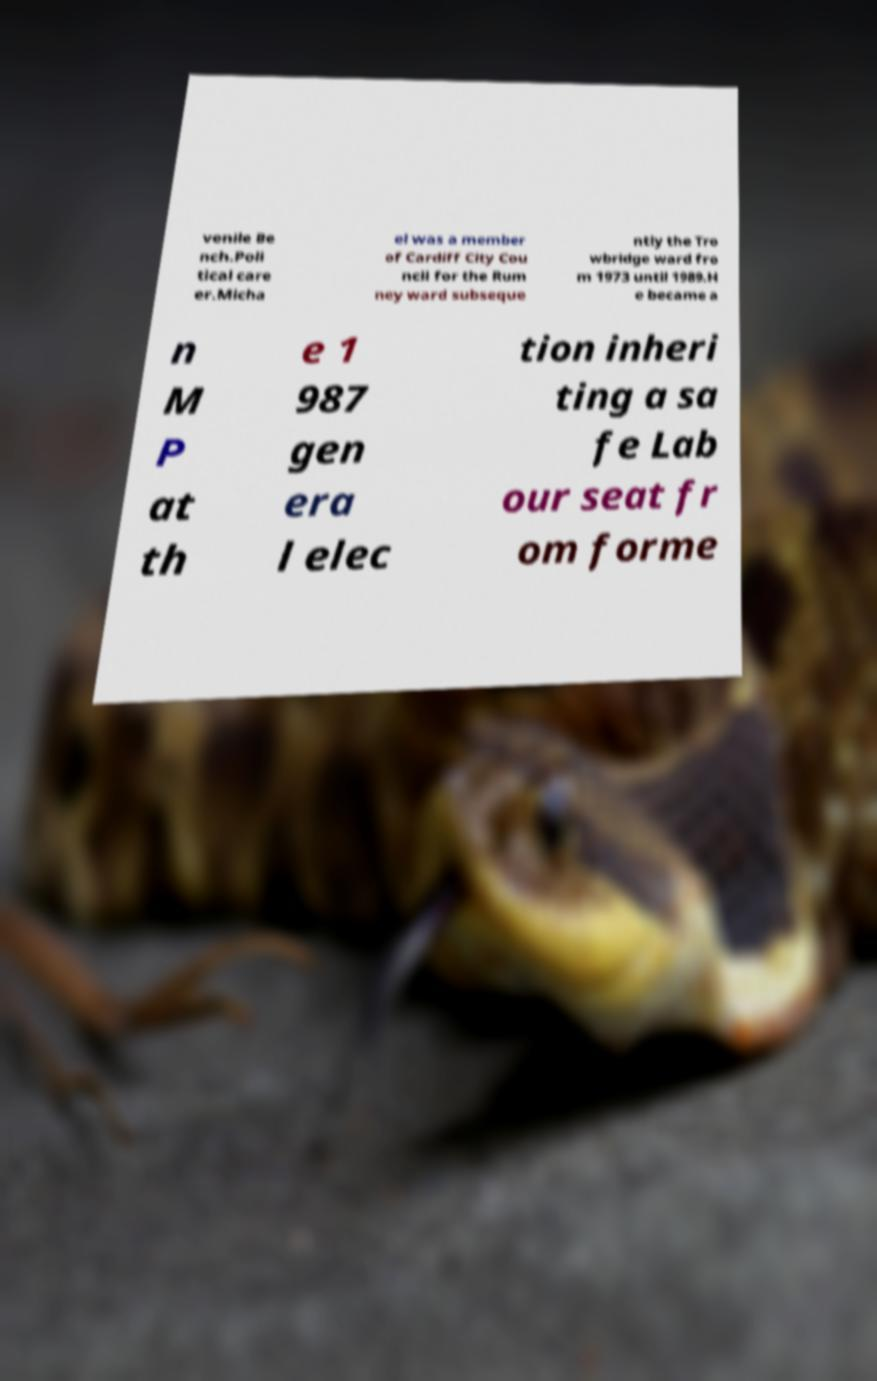Please identify and transcribe the text found in this image. venile Be nch.Poli tical care er.Micha el was a member of Cardiff City Cou ncil for the Rum ney ward subseque ntly the Tro wbridge ward fro m 1973 until 1989.H e became a n M P at th e 1 987 gen era l elec tion inheri ting a sa fe Lab our seat fr om forme 